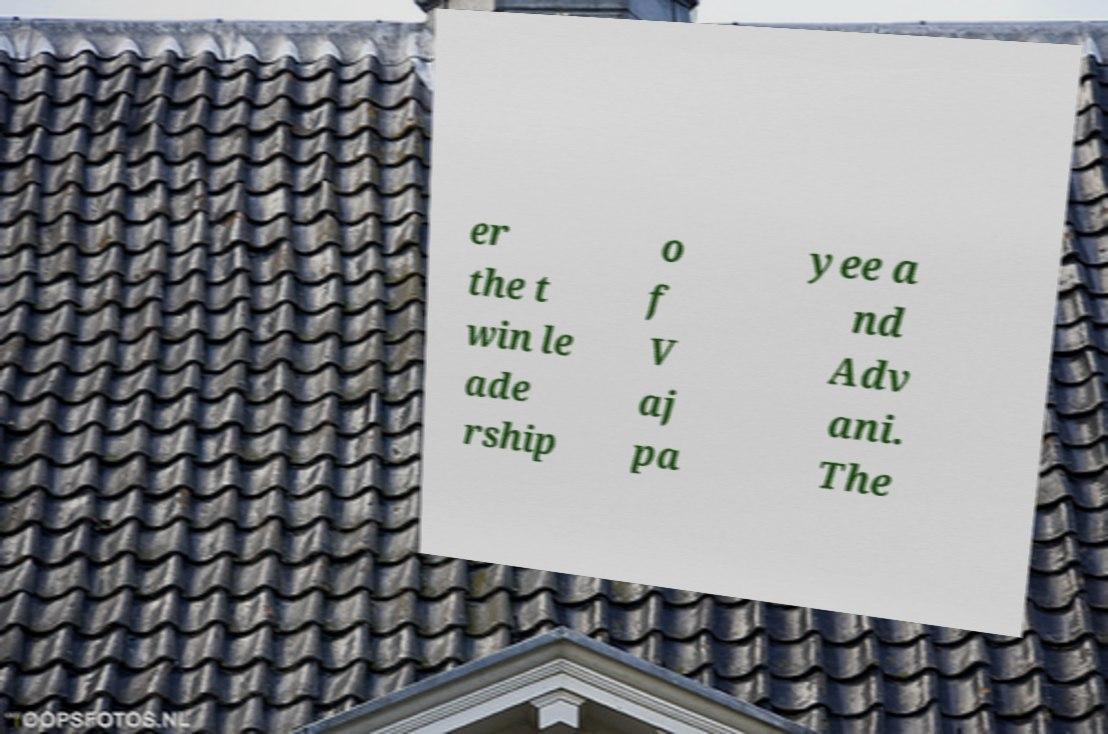Can you accurately transcribe the text from the provided image for me? er the t win le ade rship o f V aj pa yee a nd Adv ani. The 